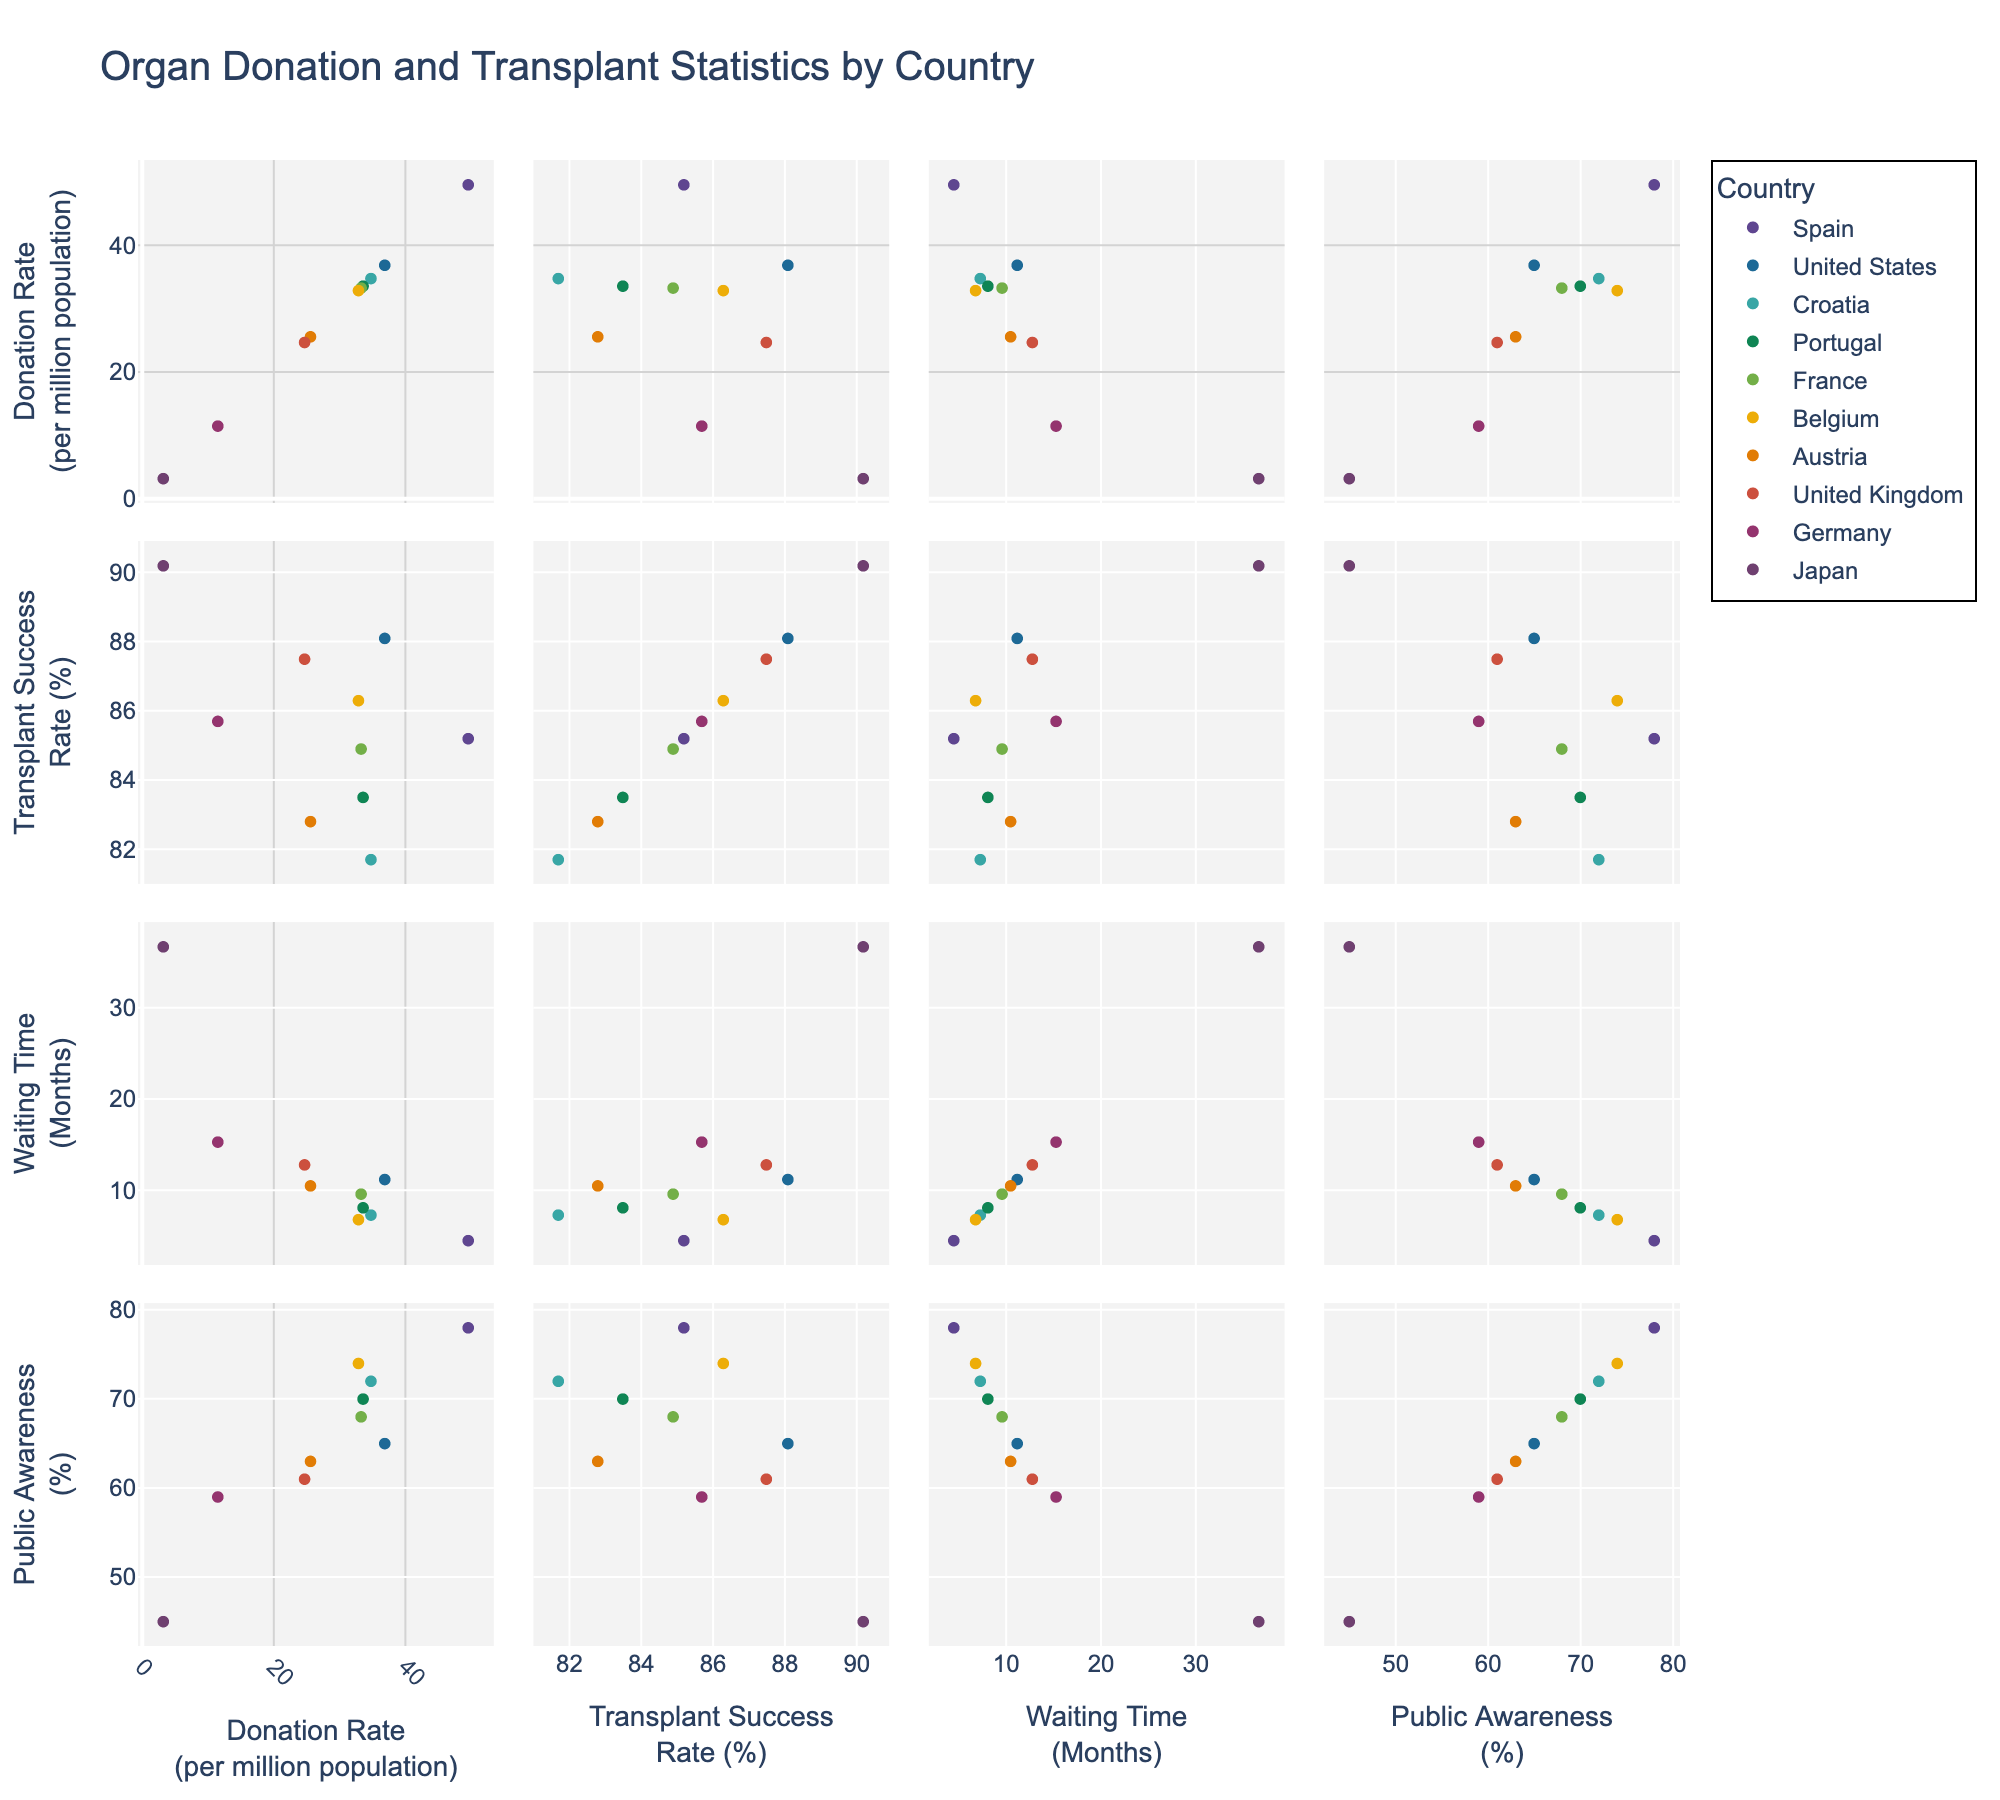What is the title of the figure? The title is prominently displayed at the top center of the figure, indicating its purpose. The text is larger and bold.
Answer: Investment Distribution Across Technology Sectors Which sector has the technology with the highest investment? Looking at the y-axes for all subplots, the highest investment level is associated with 'Autonomous Vehicles' under the Robotics sector, which reaches $1200M.
Answer: Robotics How many funding rounds does Immunotherapy in the Biotech sector have? Locate the subplot titled "Biotech." Find the bubble corresponding to 'Immunotherapy' and check its size, noting that in the hover template or marker size. The bubble represents 4 funding rounds.
Answer: 4 Which sector has the smallest technology investments overall? Scan all subplots and compare the y-axis values. The Clean Energy sector has comparably lower maximum investments, with its highest being 'Solar Power' at $680M.
Answer: Clean Energy What is the total investment in AI sector technologies? Sum up the investment amounts in the bubbles for AI-related technologies. (Machine Learning: 850 + NLP: 620 + Computer Vision: 480) = $1950M.
Answer: $1950M How does the investment in Gene Editing compare to Computer Vision? Look at the y-axes in the subplots for Biotech and AI. Gene Editing has an investment of $950M, while Computer Vision has $480M. Therefore, Gene Editing has a higher investment.
Answer: Gene Editing has higher investment Which technology in Fintech has the least number of funding rounds? Check the subplot for Fintech. The bubbles indicate 'Robo-Advisors' has the smallest number, represented by the smallest bubble size of 2.
Answer: Robo-Advisors What is the average investment in Clean Energy sector technologies? Add up the Clean Energy investments (Solar Power: 680 + Wind Energy: 520 + Energy Storage: 430), then divide by the number of technologies (3). (680 + 520 + 430) / 3 = 1630 / 3 = $543.33M.
Answer: $543.33M 